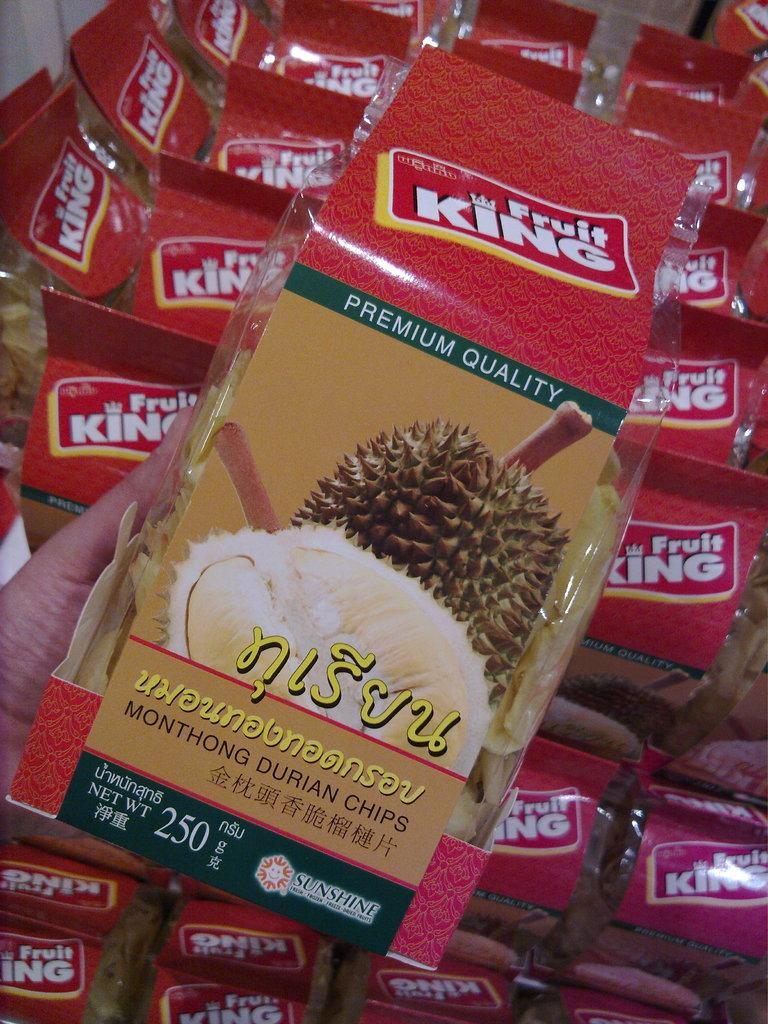What is the person in the image holding? The person is holding a packet of packed fruits in the image. Are there any other similar items visible in the image? Yes, there are multiple other packets visible in the image. What type of prose is being written on the packets in the image? There is no prose visible on the packets in the image; they are simply labeled with the contents. 